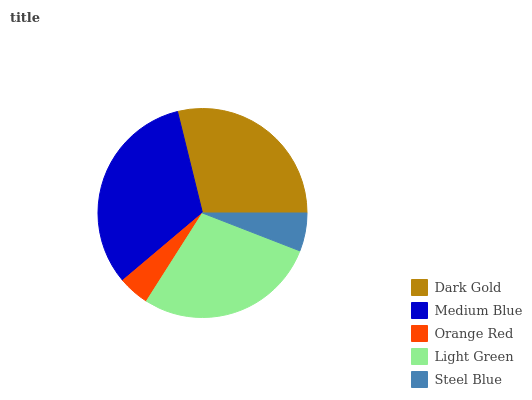Is Orange Red the minimum?
Answer yes or no. Yes. Is Medium Blue the maximum?
Answer yes or no. Yes. Is Medium Blue the minimum?
Answer yes or no. No. Is Orange Red the maximum?
Answer yes or no. No. Is Medium Blue greater than Orange Red?
Answer yes or no. Yes. Is Orange Red less than Medium Blue?
Answer yes or no. Yes. Is Orange Red greater than Medium Blue?
Answer yes or no. No. Is Medium Blue less than Orange Red?
Answer yes or no. No. Is Light Green the high median?
Answer yes or no. Yes. Is Light Green the low median?
Answer yes or no. Yes. Is Dark Gold the high median?
Answer yes or no. No. Is Medium Blue the low median?
Answer yes or no. No. 